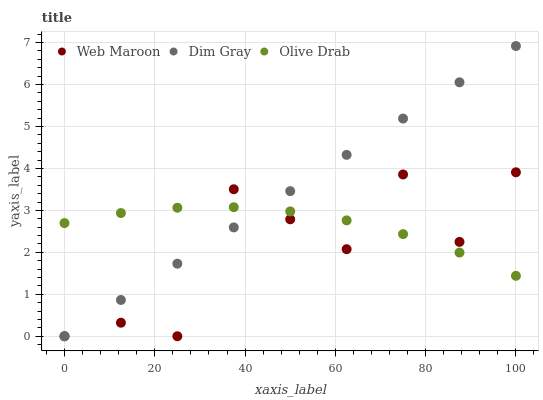Does Web Maroon have the minimum area under the curve?
Answer yes or no. Yes. Does Dim Gray have the maximum area under the curve?
Answer yes or no. Yes. Does Olive Drab have the minimum area under the curve?
Answer yes or no. No. Does Olive Drab have the maximum area under the curve?
Answer yes or no. No. Is Dim Gray the smoothest?
Answer yes or no. Yes. Is Web Maroon the roughest?
Answer yes or no. Yes. Is Olive Drab the smoothest?
Answer yes or no. No. Is Olive Drab the roughest?
Answer yes or no. No. Does Dim Gray have the lowest value?
Answer yes or no. Yes. Does Olive Drab have the lowest value?
Answer yes or no. No. Does Dim Gray have the highest value?
Answer yes or no. Yes. Does Web Maroon have the highest value?
Answer yes or no. No. Does Web Maroon intersect Olive Drab?
Answer yes or no. Yes. Is Web Maroon less than Olive Drab?
Answer yes or no. No. Is Web Maroon greater than Olive Drab?
Answer yes or no. No. 